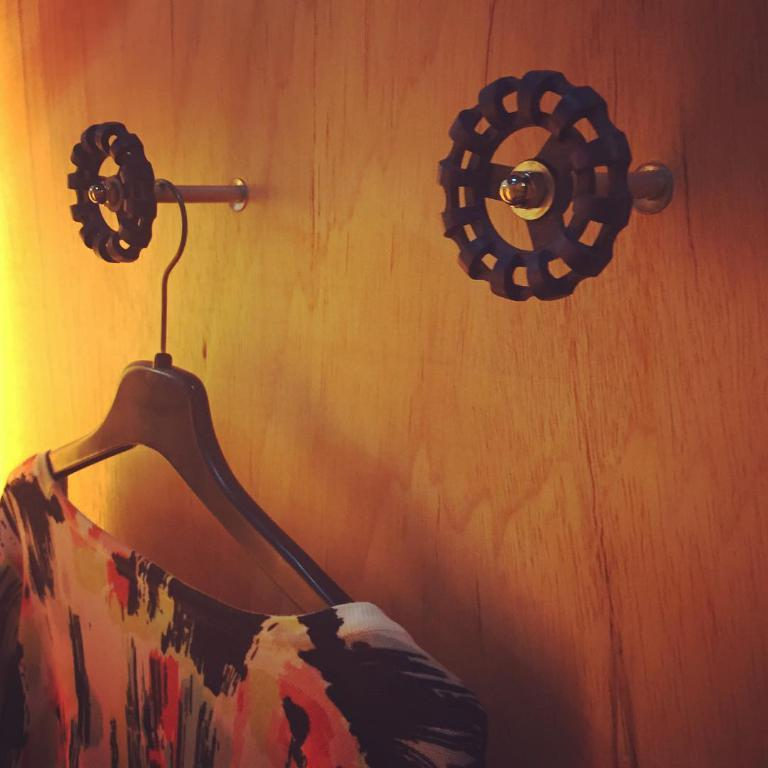What type of clothing item is visible in the image? There is a dress in the image. What can be seen on the wall in the image? There are hangers on the wall in the image. How many cats are sitting on the dress in the image? There are no cats present in the image. What is the distance between the dress and the wall in the image? The distance between the dress and the wall cannot be determined from the image. 